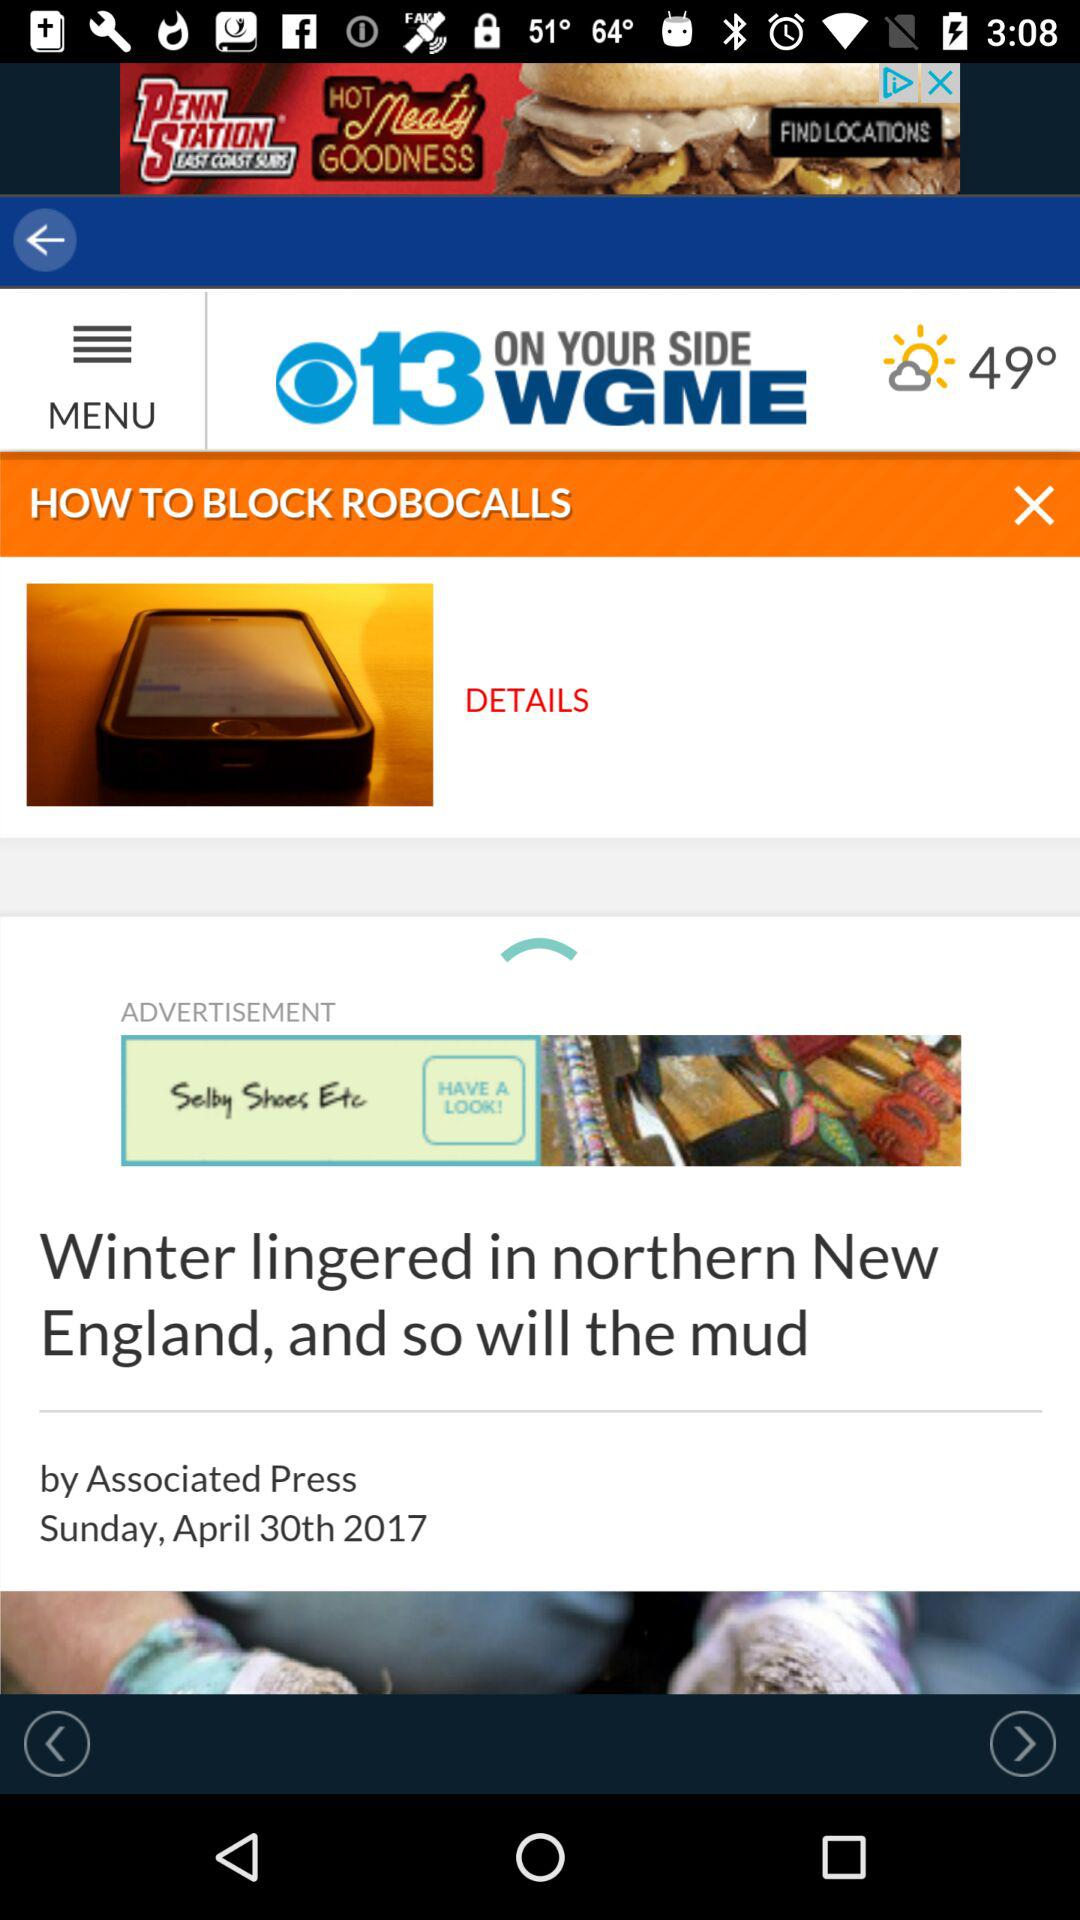How many degrees is the difference between the current temperature and the dew point?
Answer the question using a single word or phrase. 24 